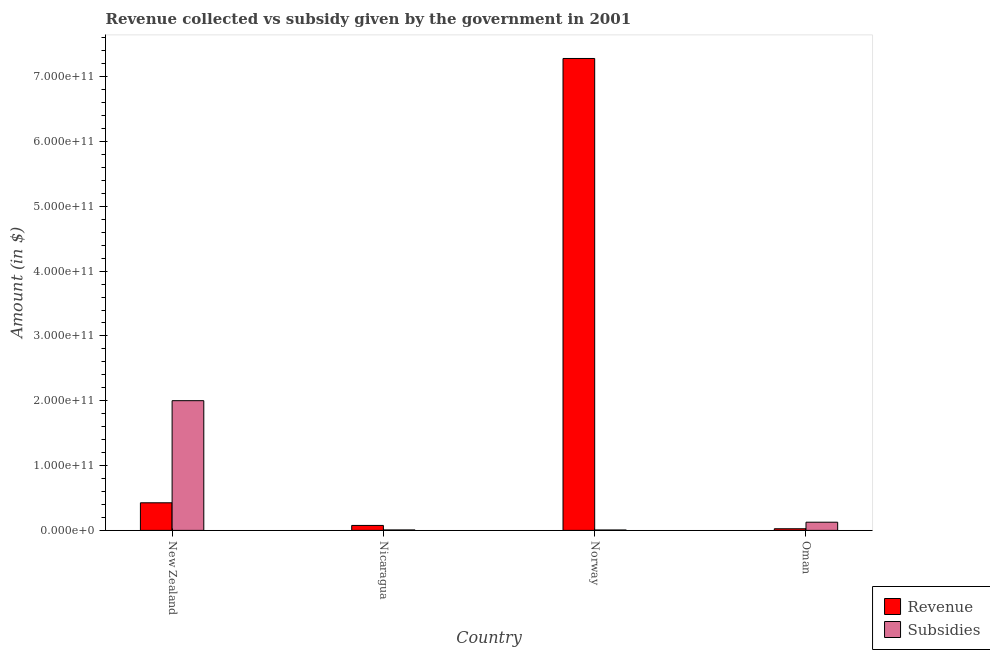How many groups of bars are there?
Your answer should be compact. 4. How many bars are there on the 3rd tick from the right?
Give a very brief answer. 2. What is the label of the 4th group of bars from the left?
Your answer should be very brief. Oman. What is the amount of subsidies given in Oman?
Make the answer very short. 1.26e+1. Across all countries, what is the maximum amount of revenue collected?
Your answer should be very brief. 7.28e+11. Across all countries, what is the minimum amount of subsidies given?
Your response must be concise. 6.18e+08. In which country was the amount of subsidies given maximum?
Offer a very short reply. New Zealand. In which country was the amount of revenue collected minimum?
Keep it short and to the point. Oman. What is the total amount of revenue collected in the graph?
Give a very brief answer. 7.81e+11. What is the difference between the amount of subsidies given in Nicaragua and that in Norway?
Give a very brief answer. 6.60e+07. What is the difference between the amount of revenue collected in New Zealand and the amount of subsidies given in Norway?
Offer a terse response. 4.20e+1. What is the average amount of subsidies given per country?
Make the answer very short. 5.35e+1. What is the difference between the amount of subsidies given and amount of revenue collected in Nicaragua?
Your answer should be very brief. -6.96e+09. What is the ratio of the amount of subsidies given in Nicaragua to that in Norway?
Provide a succinct answer. 1.11. Is the difference between the amount of subsidies given in Nicaragua and Oman greater than the difference between the amount of revenue collected in Nicaragua and Oman?
Provide a short and direct response. No. What is the difference between the highest and the second highest amount of subsidies given?
Your answer should be compact. 1.88e+11. What is the difference between the highest and the lowest amount of revenue collected?
Your answer should be compact. 7.26e+11. In how many countries, is the amount of subsidies given greater than the average amount of subsidies given taken over all countries?
Offer a terse response. 1. Is the sum of the amount of revenue collected in New Zealand and Norway greater than the maximum amount of subsidies given across all countries?
Offer a very short reply. Yes. What does the 1st bar from the left in Oman represents?
Offer a very short reply. Revenue. What does the 2nd bar from the right in Norway represents?
Keep it short and to the point. Revenue. Are all the bars in the graph horizontal?
Provide a succinct answer. No. How many countries are there in the graph?
Keep it short and to the point. 4. What is the difference between two consecutive major ticks on the Y-axis?
Keep it short and to the point. 1.00e+11. How are the legend labels stacked?
Offer a very short reply. Vertical. What is the title of the graph?
Offer a very short reply. Revenue collected vs subsidy given by the government in 2001. What is the label or title of the Y-axis?
Your answer should be compact. Amount (in $). What is the Amount (in $) in Revenue in New Zealand?
Your answer should be very brief. 4.26e+1. What is the Amount (in $) in Subsidies in New Zealand?
Offer a terse response. 2.00e+11. What is the Amount (in $) of Revenue in Nicaragua?
Your answer should be compact. 7.64e+09. What is the Amount (in $) of Subsidies in Nicaragua?
Give a very brief answer. 6.84e+08. What is the Amount (in $) in Revenue in Norway?
Offer a very short reply. 7.28e+11. What is the Amount (in $) in Subsidies in Norway?
Offer a very short reply. 6.18e+08. What is the Amount (in $) of Revenue in Oman?
Keep it short and to the point. 2.52e+09. What is the Amount (in $) in Subsidies in Oman?
Offer a very short reply. 1.26e+1. Across all countries, what is the maximum Amount (in $) in Revenue?
Ensure brevity in your answer.  7.28e+11. Across all countries, what is the maximum Amount (in $) of Subsidies?
Offer a very short reply. 2.00e+11. Across all countries, what is the minimum Amount (in $) of Revenue?
Keep it short and to the point. 2.52e+09. Across all countries, what is the minimum Amount (in $) of Subsidies?
Ensure brevity in your answer.  6.18e+08. What is the total Amount (in $) of Revenue in the graph?
Ensure brevity in your answer.  7.81e+11. What is the total Amount (in $) of Subsidies in the graph?
Keep it short and to the point. 2.14e+11. What is the difference between the Amount (in $) in Revenue in New Zealand and that in Nicaragua?
Ensure brevity in your answer.  3.49e+1. What is the difference between the Amount (in $) of Subsidies in New Zealand and that in Nicaragua?
Offer a terse response. 1.99e+11. What is the difference between the Amount (in $) of Revenue in New Zealand and that in Norway?
Offer a terse response. -6.86e+11. What is the difference between the Amount (in $) in Subsidies in New Zealand and that in Norway?
Ensure brevity in your answer.  2.00e+11. What is the difference between the Amount (in $) in Revenue in New Zealand and that in Oman?
Provide a succinct answer. 4.01e+1. What is the difference between the Amount (in $) of Subsidies in New Zealand and that in Oman?
Offer a very short reply. 1.88e+11. What is the difference between the Amount (in $) in Revenue in Nicaragua and that in Norway?
Offer a very short reply. -7.21e+11. What is the difference between the Amount (in $) of Subsidies in Nicaragua and that in Norway?
Offer a terse response. 6.60e+07. What is the difference between the Amount (in $) in Revenue in Nicaragua and that in Oman?
Your answer should be very brief. 5.13e+09. What is the difference between the Amount (in $) of Subsidies in Nicaragua and that in Oman?
Ensure brevity in your answer.  -1.19e+1. What is the difference between the Amount (in $) in Revenue in Norway and that in Oman?
Give a very brief answer. 7.26e+11. What is the difference between the Amount (in $) of Subsidies in Norway and that in Oman?
Provide a short and direct response. -1.20e+1. What is the difference between the Amount (in $) of Revenue in New Zealand and the Amount (in $) of Subsidies in Nicaragua?
Your answer should be very brief. 4.19e+1. What is the difference between the Amount (in $) in Revenue in New Zealand and the Amount (in $) in Subsidies in Norway?
Your answer should be very brief. 4.20e+1. What is the difference between the Amount (in $) of Revenue in New Zealand and the Amount (in $) of Subsidies in Oman?
Keep it short and to the point. 3.00e+1. What is the difference between the Amount (in $) of Revenue in Nicaragua and the Amount (in $) of Subsidies in Norway?
Offer a terse response. 7.03e+09. What is the difference between the Amount (in $) in Revenue in Nicaragua and the Amount (in $) in Subsidies in Oman?
Ensure brevity in your answer.  -4.98e+09. What is the difference between the Amount (in $) of Revenue in Norway and the Amount (in $) of Subsidies in Oman?
Give a very brief answer. 7.16e+11. What is the average Amount (in $) of Revenue per country?
Provide a short and direct response. 1.95e+11. What is the average Amount (in $) in Subsidies per country?
Provide a succinct answer. 5.35e+1. What is the difference between the Amount (in $) of Revenue and Amount (in $) of Subsidies in New Zealand?
Make the answer very short. -1.58e+11. What is the difference between the Amount (in $) of Revenue and Amount (in $) of Subsidies in Nicaragua?
Your answer should be compact. 6.96e+09. What is the difference between the Amount (in $) of Revenue and Amount (in $) of Subsidies in Norway?
Your answer should be very brief. 7.28e+11. What is the difference between the Amount (in $) in Revenue and Amount (in $) in Subsidies in Oman?
Your answer should be compact. -1.01e+1. What is the ratio of the Amount (in $) in Revenue in New Zealand to that in Nicaragua?
Offer a very short reply. 5.57. What is the ratio of the Amount (in $) in Subsidies in New Zealand to that in Nicaragua?
Make the answer very short. 292.47. What is the ratio of the Amount (in $) of Revenue in New Zealand to that in Norway?
Offer a terse response. 0.06. What is the ratio of the Amount (in $) of Subsidies in New Zealand to that in Norway?
Provide a succinct answer. 323.67. What is the ratio of the Amount (in $) of Revenue in New Zealand to that in Oman?
Offer a very short reply. 16.91. What is the ratio of the Amount (in $) in Subsidies in New Zealand to that in Oman?
Your answer should be very brief. 15.86. What is the ratio of the Amount (in $) in Revenue in Nicaragua to that in Norway?
Your response must be concise. 0.01. What is the ratio of the Amount (in $) of Subsidies in Nicaragua to that in Norway?
Offer a very short reply. 1.11. What is the ratio of the Amount (in $) in Revenue in Nicaragua to that in Oman?
Offer a very short reply. 3.04. What is the ratio of the Amount (in $) in Subsidies in Nicaragua to that in Oman?
Keep it short and to the point. 0.05. What is the ratio of the Amount (in $) in Revenue in Norway to that in Oman?
Offer a very short reply. 289.26. What is the ratio of the Amount (in $) of Subsidies in Norway to that in Oman?
Keep it short and to the point. 0.05. What is the difference between the highest and the second highest Amount (in $) in Revenue?
Your response must be concise. 6.86e+11. What is the difference between the highest and the second highest Amount (in $) in Subsidies?
Your answer should be very brief. 1.88e+11. What is the difference between the highest and the lowest Amount (in $) of Revenue?
Keep it short and to the point. 7.26e+11. What is the difference between the highest and the lowest Amount (in $) in Subsidies?
Your answer should be very brief. 2.00e+11. 